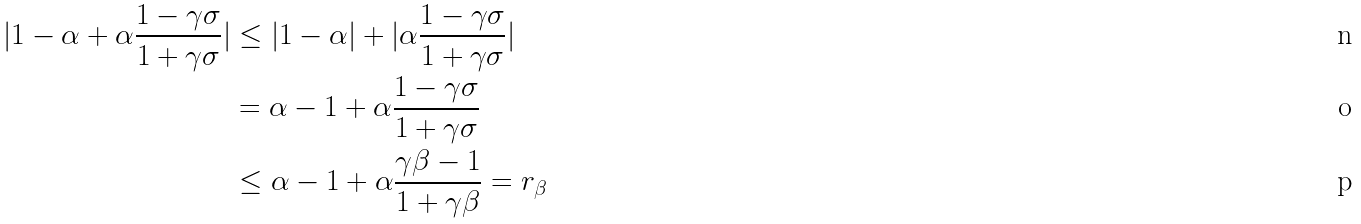Convert formula to latex. <formula><loc_0><loc_0><loc_500><loc_500>| 1 - \alpha + \alpha \frac { 1 - \gamma \sigma } { 1 + \gamma \sigma } | & \leq | 1 - \alpha | + | \alpha \frac { 1 - \gamma \sigma } { 1 + \gamma \sigma } | \\ & = \alpha - 1 + \alpha \frac { 1 - \gamma \sigma } { 1 + \gamma \sigma } \\ & \leq \alpha - 1 + \alpha \frac { \gamma \beta - 1 } { 1 + \gamma \beta } = r _ { \beta }</formula> 